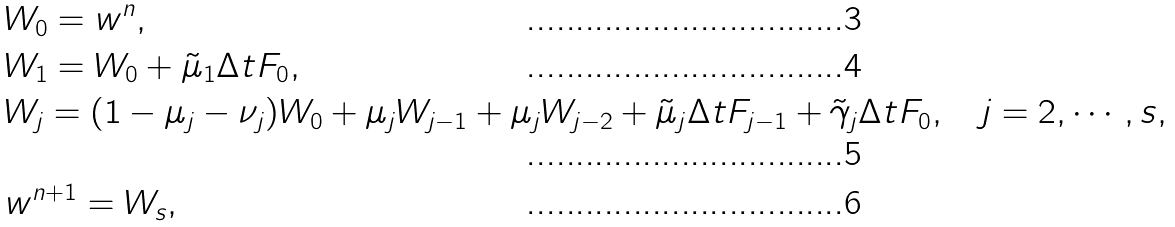<formula> <loc_0><loc_0><loc_500><loc_500>& W _ { 0 } = w ^ { n } , \\ & W _ { 1 } = W _ { 0 } + \tilde { \mu } _ { 1 } \Delta t F _ { 0 } , \\ & W _ { j } = ( 1 - \mu _ { j } - \nu _ { j } ) W _ { 0 } + \mu _ { j } W _ { j - 1 } + \mu _ { j } W _ { j - 2 } + \tilde { \mu } _ { j } \Delta t F _ { j - 1 } + \tilde { \gamma } _ { j } \Delta t F _ { 0 } , \quad j = 2 , \cdots , s , \\ & w ^ { n + 1 } = W _ { s } ,</formula> 